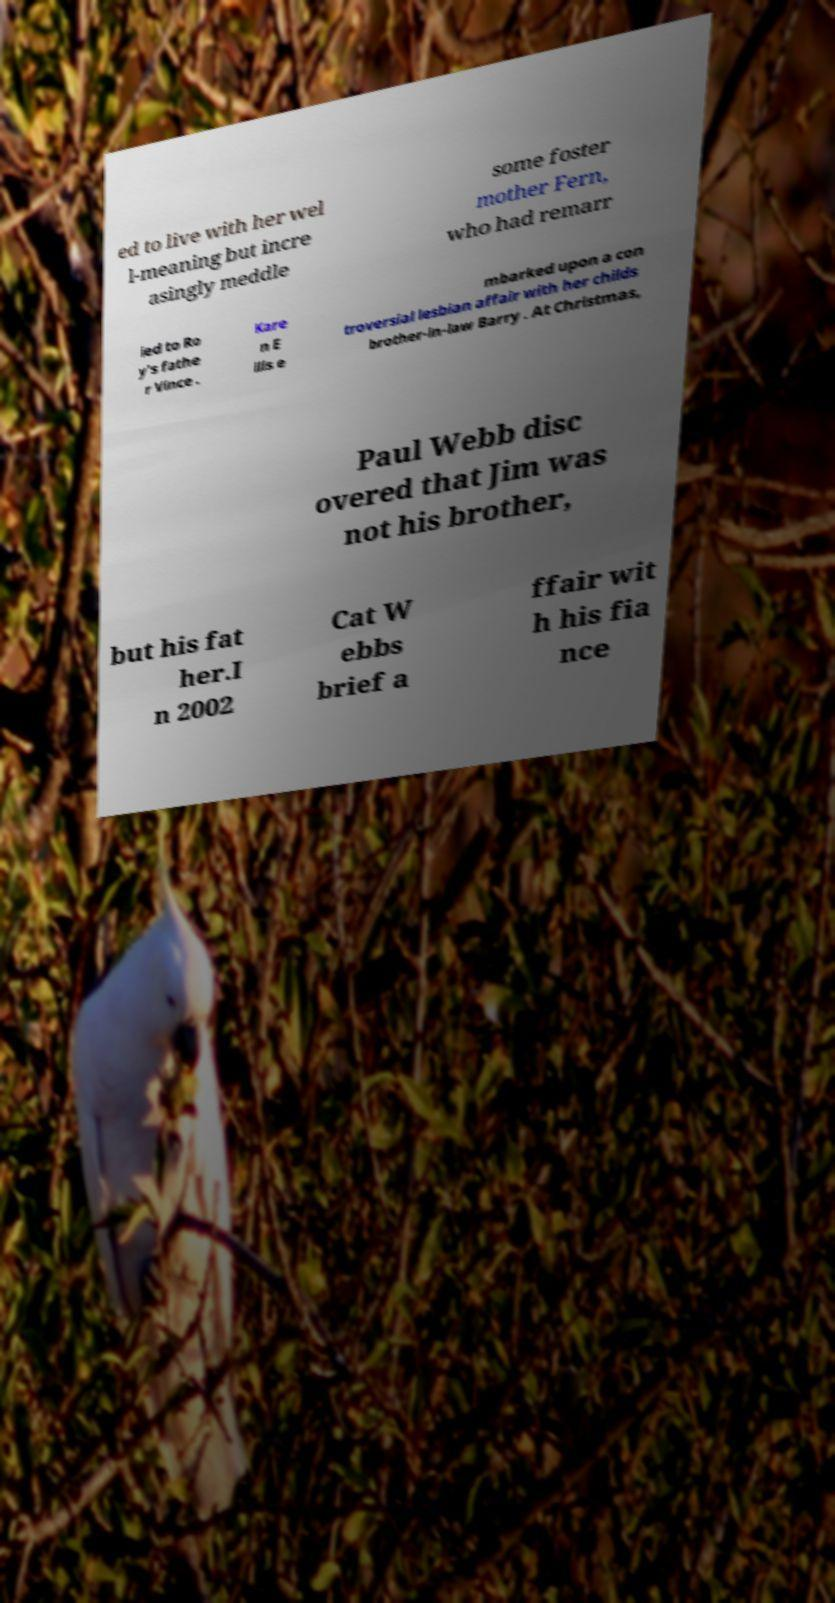There's text embedded in this image that I need extracted. Can you transcribe it verbatim? ed to live with her wel l-meaning but incre asingly meddle some foster mother Fern, who had remarr ied to Ro y's fathe r Vince . Kare n E llis e mbarked upon a con troversial lesbian affair with her childs brother-in-law Barry . At Christmas, Paul Webb disc overed that Jim was not his brother, but his fat her.I n 2002 Cat W ebbs brief a ffair wit h his fia nce 